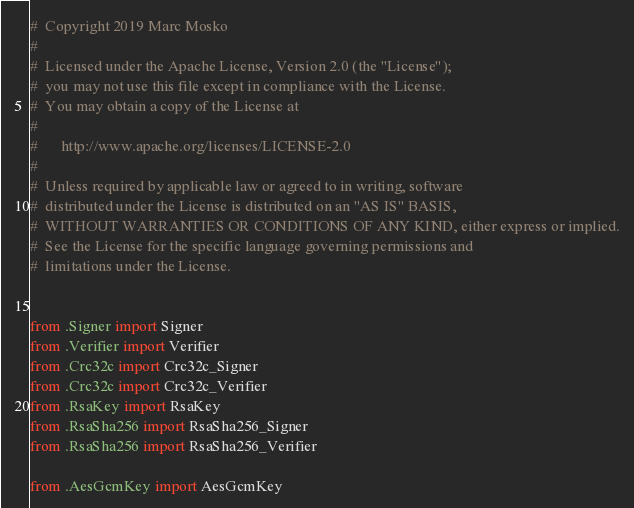Convert code to text. <code><loc_0><loc_0><loc_500><loc_500><_Python_>#  Copyright 2019 Marc Mosko
#
#  Licensed under the Apache License, Version 2.0 (the "License");
#  you may not use this file except in compliance with the License.
#  You may obtain a copy of the License at
#
#      http://www.apache.org/licenses/LICENSE-2.0
#
#  Unless required by applicable law or agreed to in writing, software
#  distributed under the License is distributed on an "AS IS" BASIS,
#  WITHOUT WARRANTIES OR CONDITIONS OF ANY KIND, either express or implied.
#  See the License for the specific language governing permissions and
#  limitations under the License.


from .Signer import Signer
from .Verifier import Verifier
from .Crc32c import Crc32c_Signer
from .Crc32c import Crc32c_Verifier
from .RsaKey import RsaKey
from .RsaSha256 import RsaSha256_Signer
from .RsaSha256 import RsaSha256_Verifier

from .AesGcmKey import AesGcmKey
</code> 